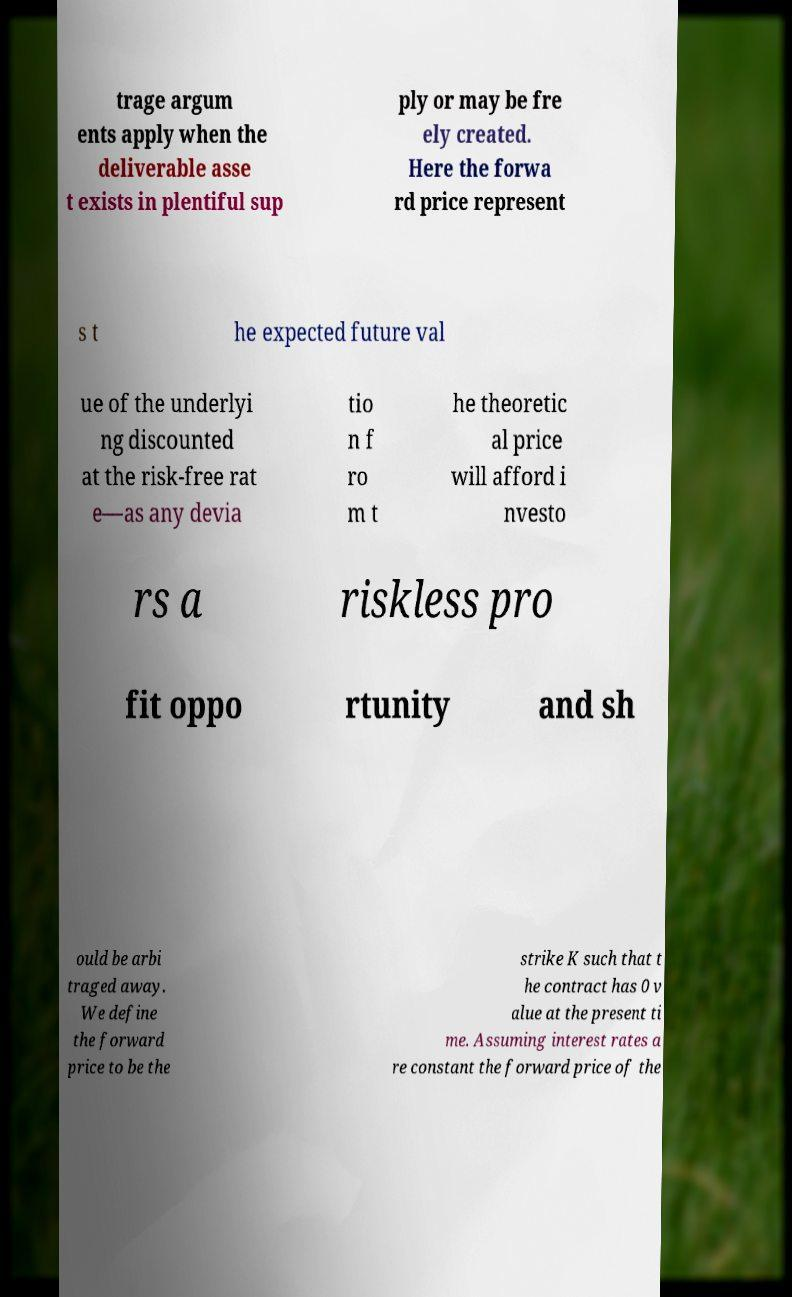There's text embedded in this image that I need extracted. Can you transcribe it verbatim? trage argum ents apply when the deliverable asse t exists in plentiful sup ply or may be fre ely created. Here the forwa rd price represent s t he expected future val ue of the underlyi ng discounted at the risk-free rat e—as any devia tio n f ro m t he theoretic al price will afford i nvesto rs a riskless pro fit oppo rtunity and sh ould be arbi traged away. We define the forward price to be the strike K such that t he contract has 0 v alue at the present ti me. Assuming interest rates a re constant the forward price of the 